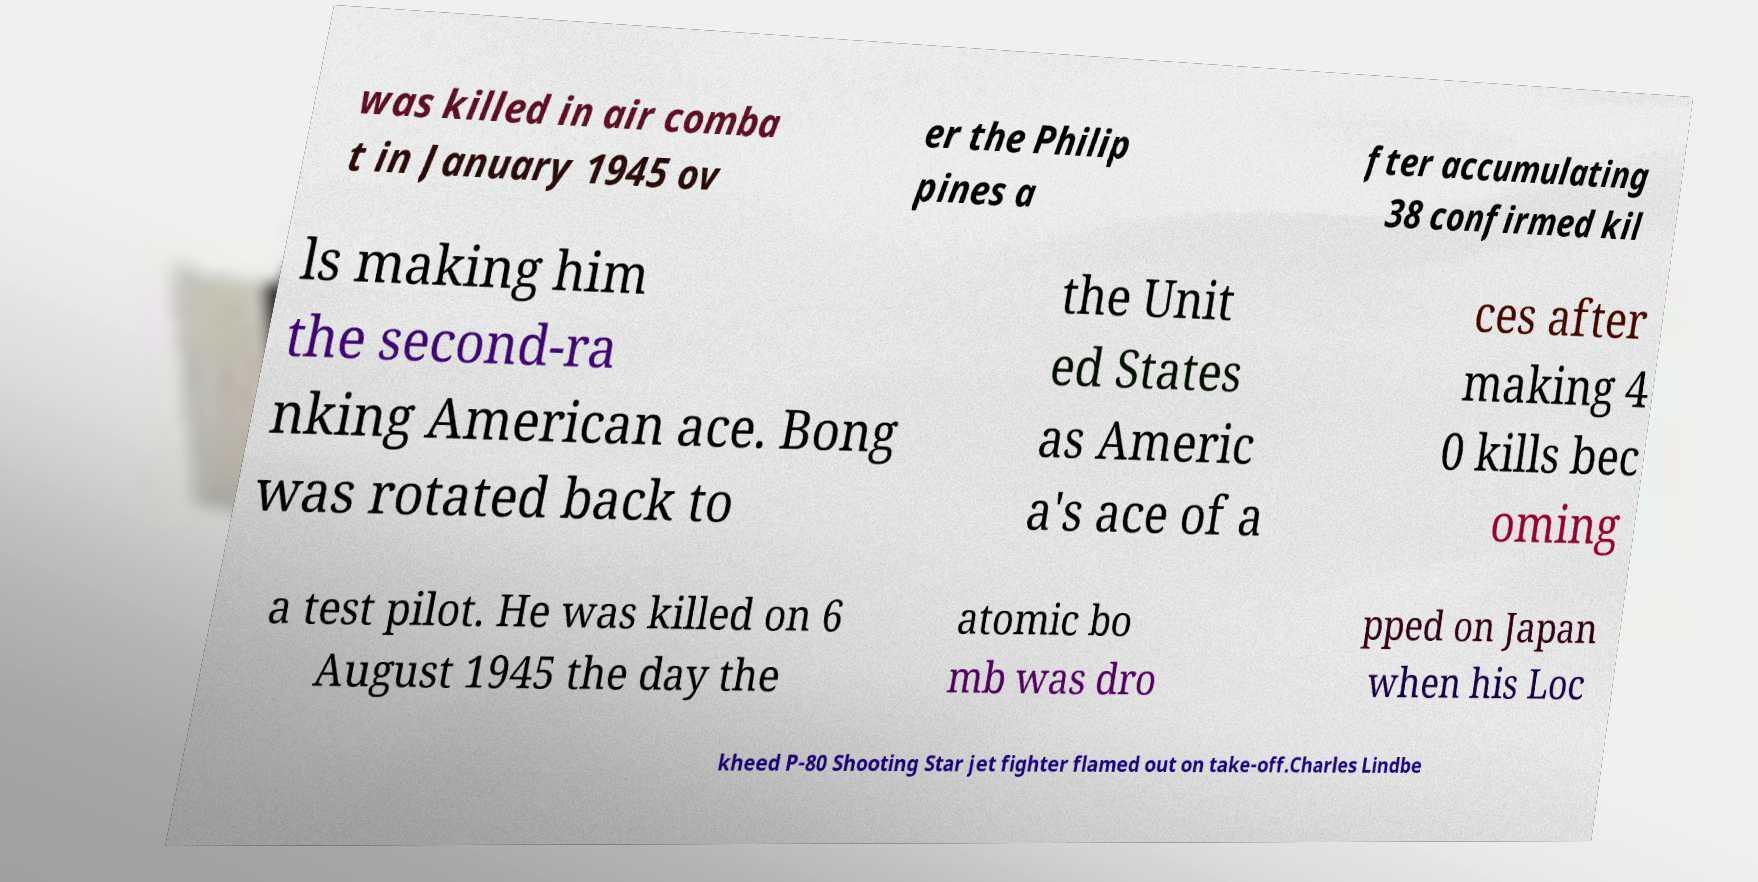Please identify and transcribe the text found in this image. was killed in air comba t in January 1945 ov er the Philip pines a fter accumulating 38 confirmed kil ls making him the second-ra nking American ace. Bong was rotated back to the Unit ed States as Americ a's ace of a ces after making 4 0 kills bec oming a test pilot. He was killed on 6 August 1945 the day the atomic bo mb was dro pped on Japan when his Loc kheed P-80 Shooting Star jet fighter flamed out on take-off.Charles Lindbe 